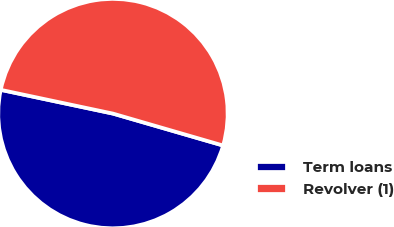Convert chart to OTSL. <chart><loc_0><loc_0><loc_500><loc_500><pie_chart><fcel>Term loans<fcel>Revolver (1)<nl><fcel>48.83%<fcel>51.17%<nl></chart> 